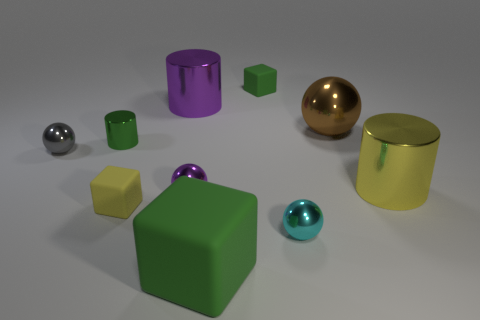Subtract all cylinders. How many objects are left? 7 Add 5 cyan metallic objects. How many cyan metallic objects exist? 6 Subtract 1 purple balls. How many objects are left? 9 Subtract all cyan metallic things. Subtract all purple things. How many objects are left? 7 Add 4 metallic spheres. How many metallic spheres are left? 8 